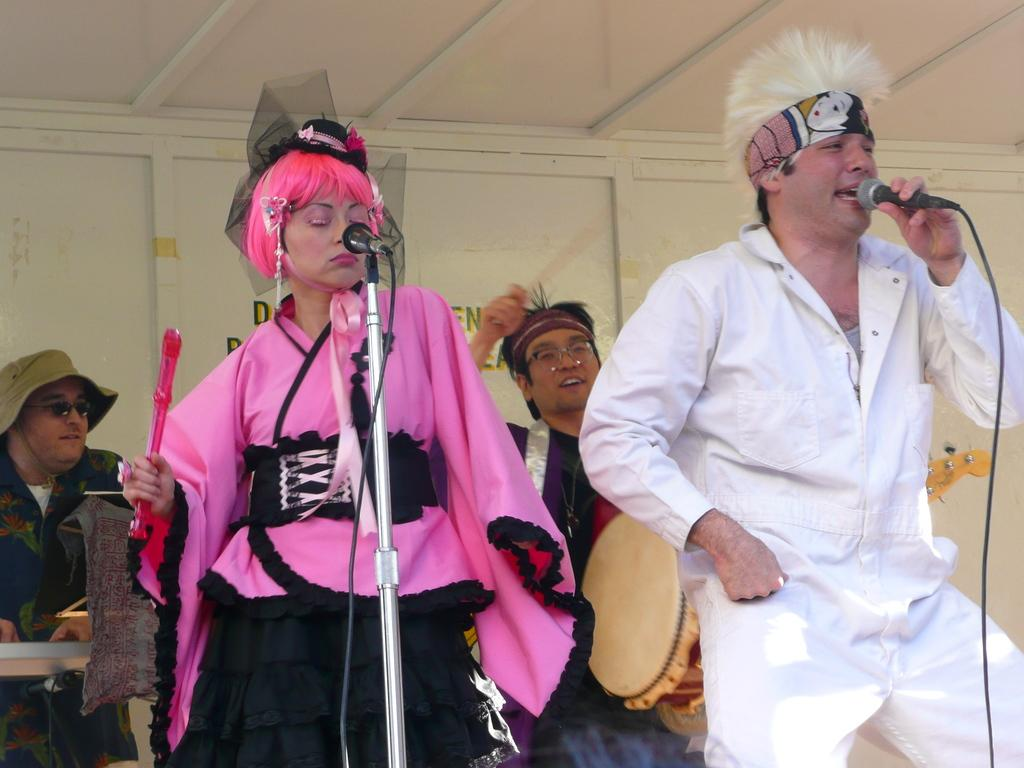How many people are visible in the image? There are two people standing in the image. What is one of the people doing? One person is holding a microphone. What is the person with the microphone doing? The person holding the microphone is singing a song. Can you describe the people in the background? There are two other people in the background, and they are playing a musical instrument. What type of trade is being conducted in the image? There is no trade being conducted in the image; it features people singing and playing musical instruments. 